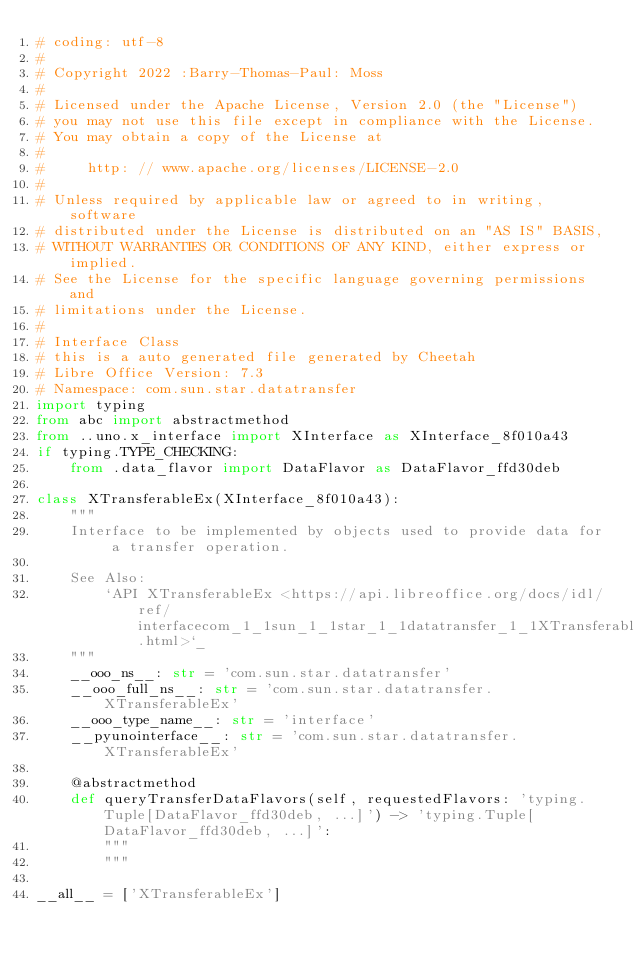Convert code to text. <code><loc_0><loc_0><loc_500><loc_500><_Python_># coding: utf-8
#
# Copyright 2022 :Barry-Thomas-Paul: Moss
#
# Licensed under the Apache License, Version 2.0 (the "License")
# you may not use this file except in compliance with the License.
# You may obtain a copy of the License at
#
#     http: // www.apache.org/licenses/LICENSE-2.0
#
# Unless required by applicable law or agreed to in writing, software
# distributed under the License is distributed on an "AS IS" BASIS,
# WITHOUT WARRANTIES OR CONDITIONS OF ANY KIND, either express or implied.
# See the License for the specific language governing permissions and
# limitations under the License.
#
# Interface Class
# this is a auto generated file generated by Cheetah
# Libre Office Version: 7.3
# Namespace: com.sun.star.datatransfer
import typing
from abc import abstractmethod
from ..uno.x_interface import XInterface as XInterface_8f010a43
if typing.TYPE_CHECKING:
    from .data_flavor import DataFlavor as DataFlavor_ffd30deb

class XTransferableEx(XInterface_8f010a43):
    """
    Interface to be implemented by objects used to provide data for a transfer operation.

    See Also:
        `API XTransferableEx <https://api.libreoffice.org/docs/idl/ref/interfacecom_1_1sun_1_1star_1_1datatransfer_1_1XTransferableEx.html>`_
    """
    __ooo_ns__: str = 'com.sun.star.datatransfer'
    __ooo_full_ns__: str = 'com.sun.star.datatransfer.XTransferableEx'
    __ooo_type_name__: str = 'interface'
    __pyunointerface__: str = 'com.sun.star.datatransfer.XTransferableEx'

    @abstractmethod
    def queryTransferDataFlavors(self, requestedFlavors: 'typing.Tuple[DataFlavor_ffd30deb, ...]') -> 'typing.Tuple[DataFlavor_ffd30deb, ...]':
        """
        """

__all__ = ['XTransferableEx']

</code> 